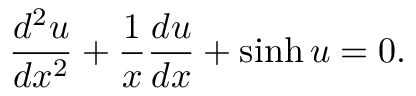Convert formula to latex. <formula><loc_0><loc_0><loc_500><loc_500>\frac { d ^ { 2 } u } { d x ^ { 2 } } + \frac { 1 } { x } \frac { d u } { d x } + \sinh u = 0 .</formula> 